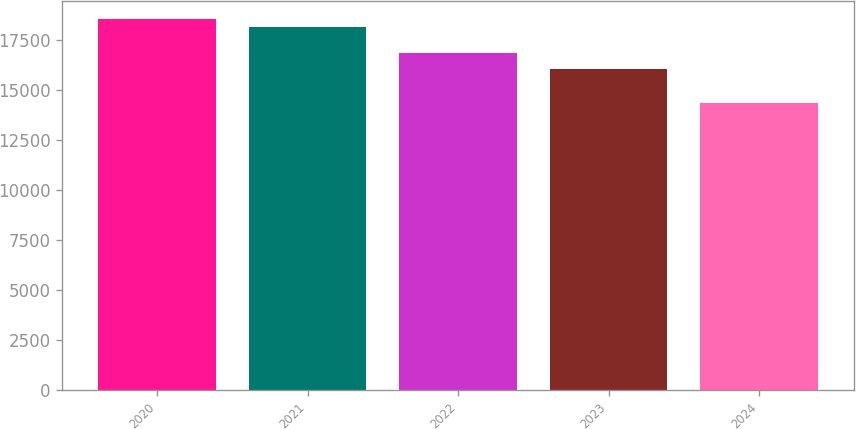<chart> <loc_0><loc_0><loc_500><loc_500><bar_chart><fcel>2020<fcel>2021<fcel>2022<fcel>2023<fcel>2024<nl><fcel>18534.1<fcel>18137<fcel>16844<fcel>16047<fcel>14360<nl></chart> 